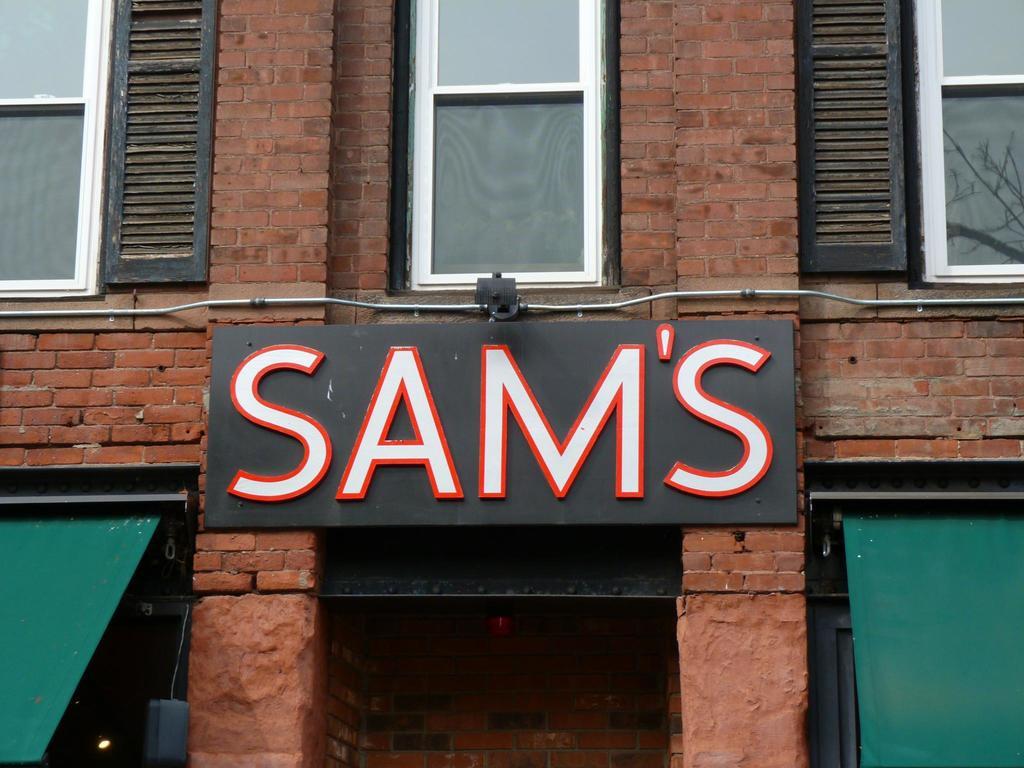What is the name of this establishment?
Your answer should be compact. Sam's. What letters does the sign begin with?
Ensure brevity in your answer.  S. 